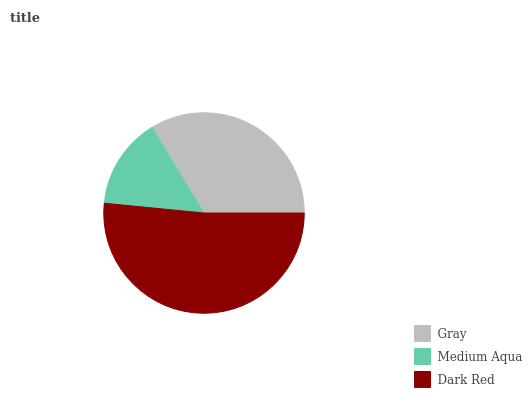Is Medium Aqua the minimum?
Answer yes or no. Yes. Is Dark Red the maximum?
Answer yes or no. Yes. Is Dark Red the minimum?
Answer yes or no. No. Is Medium Aqua the maximum?
Answer yes or no. No. Is Dark Red greater than Medium Aqua?
Answer yes or no. Yes. Is Medium Aqua less than Dark Red?
Answer yes or no. Yes. Is Medium Aqua greater than Dark Red?
Answer yes or no. No. Is Dark Red less than Medium Aqua?
Answer yes or no. No. Is Gray the high median?
Answer yes or no. Yes. Is Gray the low median?
Answer yes or no. Yes. Is Dark Red the high median?
Answer yes or no. No. Is Medium Aqua the low median?
Answer yes or no. No. 